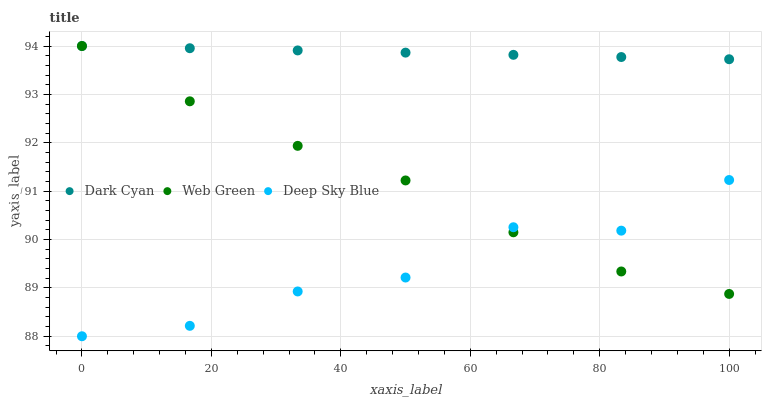Does Deep Sky Blue have the minimum area under the curve?
Answer yes or no. Yes. Does Dark Cyan have the maximum area under the curve?
Answer yes or no. Yes. Does Web Green have the minimum area under the curve?
Answer yes or no. No. Does Web Green have the maximum area under the curve?
Answer yes or no. No. Is Dark Cyan the smoothest?
Answer yes or no. Yes. Is Deep Sky Blue the roughest?
Answer yes or no. Yes. Is Web Green the smoothest?
Answer yes or no. No. Is Web Green the roughest?
Answer yes or no. No. Does Deep Sky Blue have the lowest value?
Answer yes or no. Yes. Does Web Green have the lowest value?
Answer yes or no. No. Does Web Green have the highest value?
Answer yes or no. Yes. Does Deep Sky Blue have the highest value?
Answer yes or no. No. Is Deep Sky Blue less than Dark Cyan?
Answer yes or no. Yes. Is Dark Cyan greater than Deep Sky Blue?
Answer yes or no. Yes. Does Web Green intersect Dark Cyan?
Answer yes or no. Yes. Is Web Green less than Dark Cyan?
Answer yes or no. No. Is Web Green greater than Dark Cyan?
Answer yes or no. No. Does Deep Sky Blue intersect Dark Cyan?
Answer yes or no. No. 